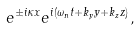<formula> <loc_0><loc_0><loc_500><loc_500>e ^ { \pm i \kappa x } e ^ { i ( \omega _ { n } t + k _ { y } y + k _ { z } z ) } ,</formula> 